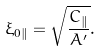<formula> <loc_0><loc_0><loc_500><loc_500>\xi _ { 0 \| } = \sqrt { \frac { C _ { \| } } { A ^ { \prime } } } .</formula> 